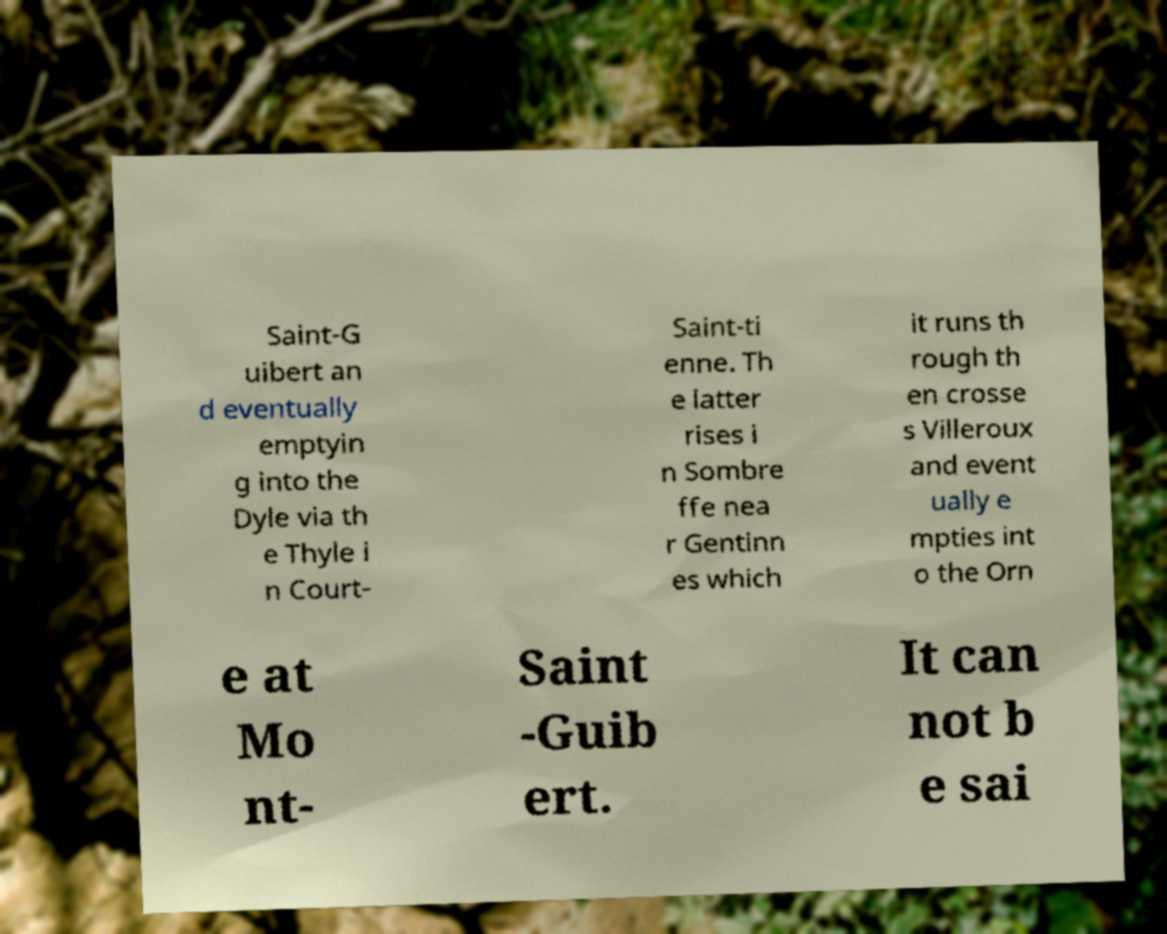There's text embedded in this image that I need extracted. Can you transcribe it verbatim? Saint-G uibert an d eventually emptyin g into the Dyle via th e Thyle i n Court- Saint-ti enne. Th e latter rises i n Sombre ffe nea r Gentinn es which it runs th rough th en crosse s Villeroux and event ually e mpties int o the Orn e at Mo nt- Saint -Guib ert. It can not b e sai 